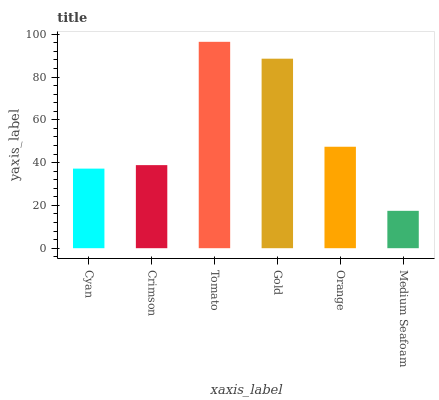Is Medium Seafoam the minimum?
Answer yes or no. Yes. Is Tomato the maximum?
Answer yes or no. Yes. Is Crimson the minimum?
Answer yes or no. No. Is Crimson the maximum?
Answer yes or no. No. Is Crimson greater than Cyan?
Answer yes or no. Yes. Is Cyan less than Crimson?
Answer yes or no. Yes. Is Cyan greater than Crimson?
Answer yes or no. No. Is Crimson less than Cyan?
Answer yes or no. No. Is Orange the high median?
Answer yes or no. Yes. Is Crimson the low median?
Answer yes or no. Yes. Is Crimson the high median?
Answer yes or no. No. Is Tomato the low median?
Answer yes or no. No. 